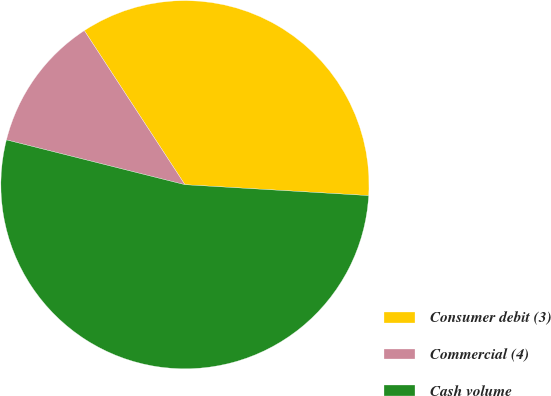Convert chart. <chart><loc_0><loc_0><loc_500><loc_500><pie_chart><fcel>Consumer debit (3)<fcel>Commercial (4)<fcel>Cash volume<nl><fcel>35.15%<fcel>11.88%<fcel>52.97%<nl></chart> 